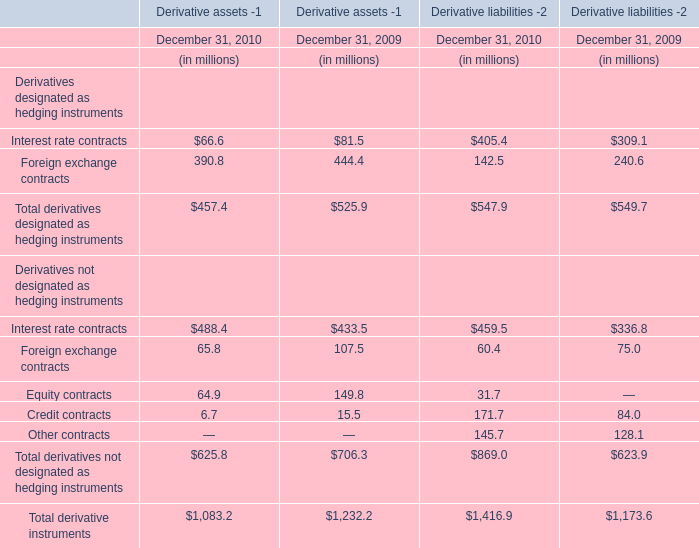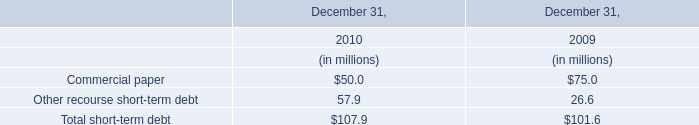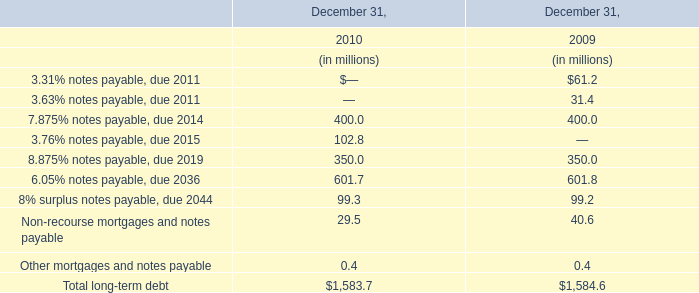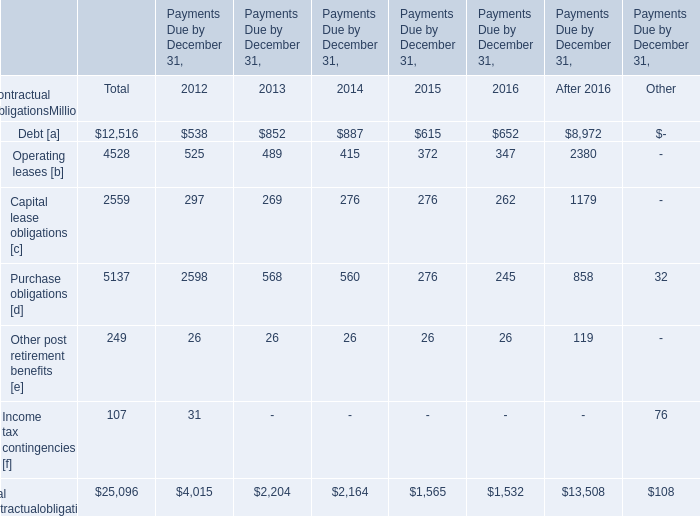What is the growing rate of Interest rate contracts in the years with the least Interest rate contracts? 
Computations: (((488.4 + 459.5) - (433.5 + 336.8)) / (433.5 + 336.8))
Answer: 0.23056. 